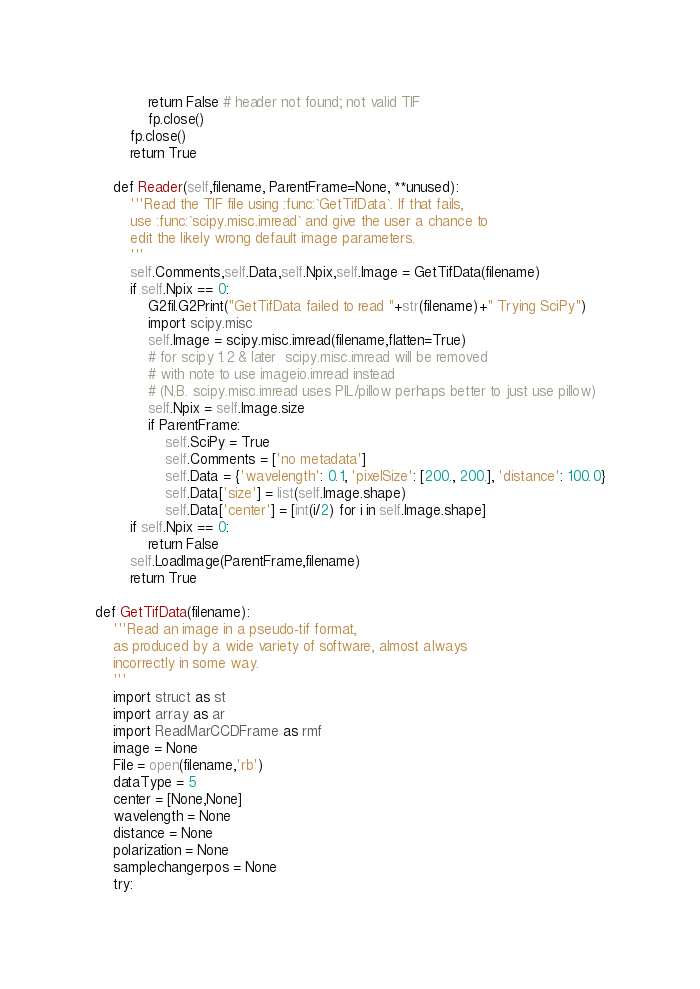<code> <loc_0><loc_0><loc_500><loc_500><_Python_>            return False # header not found; not valid TIF
            fp.close()
        fp.close()
        return True
    
    def Reader(self,filename, ParentFrame=None, **unused):
        '''Read the TIF file using :func:`GetTifData`. If that fails,
        use :func:`scipy.misc.imread` and give the user a chance to
        edit the likely wrong default image parameters. 
        '''
        self.Comments,self.Data,self.Npix,self.Image = GetTifData(filename)
        if self.Npix == 0:
            G2fil.G2Print("GetTifData failed to read "+str(filename)+" Trying SciPy")
            import scipy.misc
            self.Image = scipy.misc.imread(filename,flatten=True)
            # for scipy 1.2 & later  scipy.misc.imread will be removed
            # with note to use imageio.imread instead 
            # (N.B. scipy.misc.imread uses PIL/pillow perhaps better to just use pillow)
            self.Npix = self.Image.size
            if ParentFrame:
                self.SciPy = True
                self.Comments = ['no metadata']
                self.Data = {'wavelength': 0.1, 'pixelSize': [200., 200.], 'distance': 100.0}
                self.Data['size'] = list(self.Image.shape)
                self.Data['center'] = [int(i/2) for i in self.Image.shape]
        if self.Npix == 0:
            return False
        self.LoadImage(ParentFrame,filename)
        return True

def GetTifData(filename):
    '''Read an image in a pseudo-tif format,
    as produced by a wide variety of software, almost always
    incorrectly in some way. 
    '''
    import struct as st
    import array as ar
    import ReadMarCCDFrame as rmf
    image = None
    File = open(filename,'rb')
    dataType = 5
    center = [None,None]
    wavelength = None
    distance = None
    polarization = None
    samplechangerpos = None
    try:</code> 